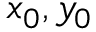<formula> <loc_0><loc_0><loc_500><loc_500>x _ { 0 } , y _ { 0 }</formula> 